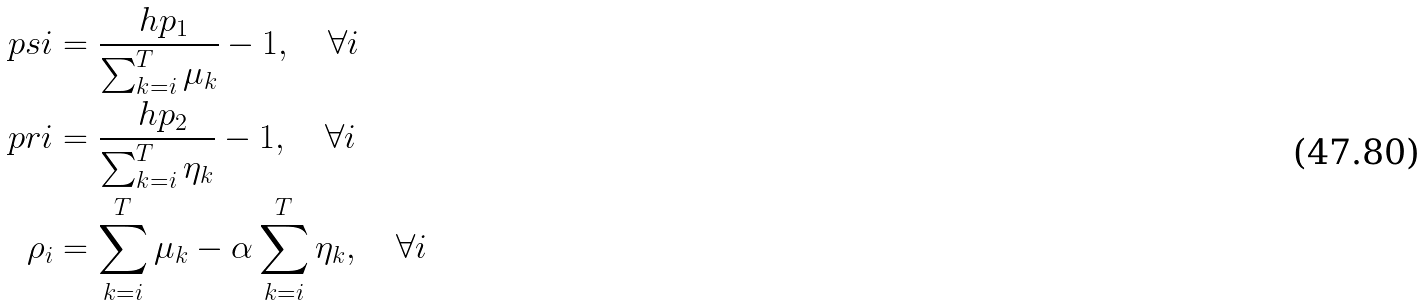Convert formula to latex. <formula><loc_0><loc_0><loc_500><loc_500>\ p s { i } & = \frac { \ h p _ { 1 } } { \sum _ { k = i } ^ { T } \mu _ { k } } - 1 , \quad \forall i \\ \ p r { i } & = \frac { \ h p _ { 2 } } { \sum _ { k = i } ^ { T } \eta _ { k } } - 1 , \quad \forall i \\ \rho _ { i } & = \sum _ { k = i } ^ { T } \mu _ { k } - \alpha \sum _ { k = i } ^ { T } \eta _ { k } , \quad \forall i</formula> 